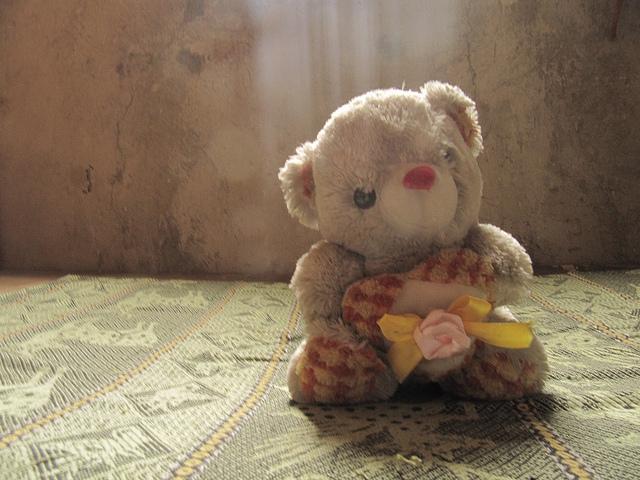What color is the bear's nose?
Answer briefly. Red. How old is the bear?
Concise answer only. 5 yrs. What color is the flower on the bear?
Answer briefly. Pink. What is the teddy bear holding?
Be succinct. Heart. 